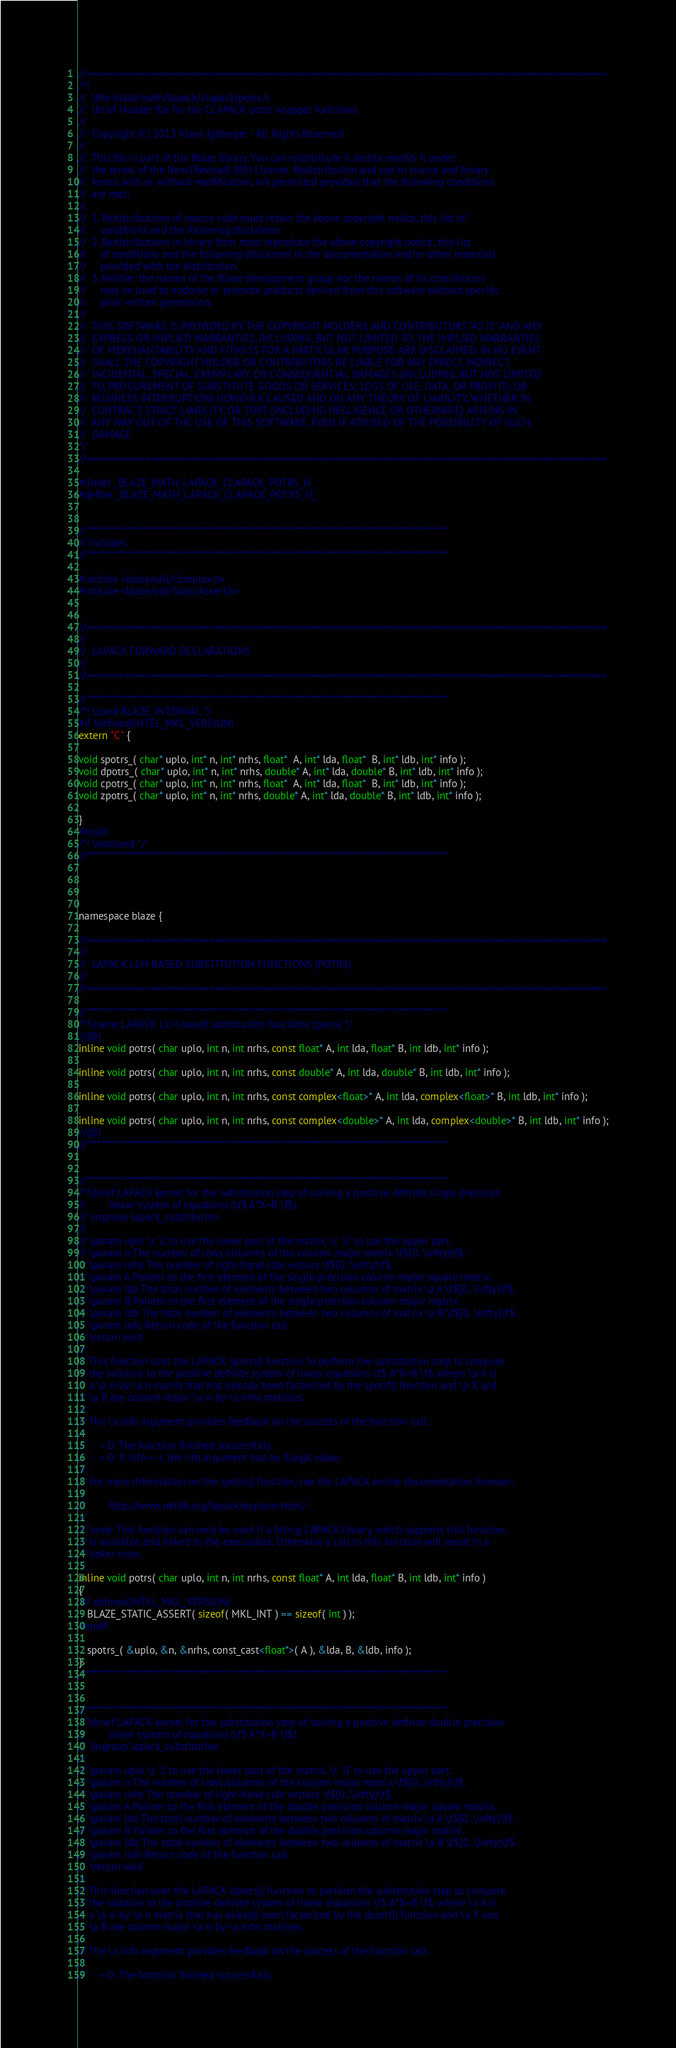Convert code to text. <code><loc_0><loc_0><loc_500><loc_500><_C_>//=================================================================================================
/*!
//  \file blaze/math/lapack/clapack/potrs.h
//  \brief Header file for the CLAPACK potrs wrapper functions
//
//  Copyright (C) 2013 Klaus Iglberger - All Rights Reserved
//
//  This file is part of the Blaze library. You can redistribute it and/or modify it under
//  the terms of the New (Revised) BSD License. Redistribution and use in source and binary
//  forms, with or without modification, are permitted provided that the following conditions
//  are met:
//
//  1. Redistributions of source code must retain the above copyright notice, this list of
//     conditions and the following disclaimer.
//  2. Redistributions in binary form must reproduce the above copyright notice, this list
//     of conditions and the following disclaimer in the documentation and/or other materials
//     provided with the distribution.
//  3. Neither the names of the Blaze development group nor the names of its contributors
//     may be used to endorse or promote products derived from this software without specific
//     prior written permission.
//
//  THIS SOFTWARE IS PROVIDED BY THE COPYRIGHT HOLDERS AND CONTRIBUTORS "AS IS" AND ANY
//  EXPRESS OR IMPLIED WARRANTIES, INCLUDING, BUT NOT LIMITED TO, THE IMPLIED WARRANTIES
//  OF MERCHANTABILITY AND FITNESS FOR A PARTICULAR PURPOSE ARE DISCLAIMED. IN NO EVENT
//  SHALL THE COPYRIGHT HOLDER OR CONTRIBUTORS BE LIABLE FOR ANY DIRECT, INDIRECT,
//  INCIDENTAL, SPECIAL, EXEMPLARY, OR CONSEQUENTIAL DAMAGES (INCLUDING, BUT NOT LIMITED
//  TO, PROCUREMENT OF SUBSTITUTE GOODS OR SERVICES; LOSS OF USE, DATA, OR PROFITS; OR
//  BUSINESS INTERRUPTION) HOWEVER CAUSED AND ON ANY THEORY OF LIABILITY, WHETHER IN
//  CONTRACT, STRICT LIABILITY, OR TORT (INCLUDING NEGLIGENCE OR OTHERWISE) ARISING IN
//  ANY WAY OUT OF THE USE OF THIS SOFTWARE, EVEN IF ADVISED OF THE POSSIBILITY OF SUCH
//  DAMAGE.
*/
//=================================================================================================

#ifndef _BLAZE_MATH_LAPACK_CLAPACK_POTRS_H_
#define _BLAZE_MATH_LAPACK_CLAPACK_POTRS_H_


//*************************************************************************************************
// Includes
//*************************************************************************************************

#include <blaze/util/Complex.h>
#include <blaze/util/StaticAssert.h>


//=================================================================================================
//
//  LAPACK FORWARD DECLARATIONS
//
//=================================================================================================

//*************************************************************************************************
/*! \cond BLAZE_INTERNAL */
#if !defined(INTEL_MKL_VERSION)
extern "C" {

void spotrs_( char* uplo, int* n, int* nrhs, float*  A, int* lda, float*  B, int* ldb, int* info );
void dpotrs_( char* uplo, int* n, int* nrhs, double* A, int* lda, double* B, int* ldb, int* info );
void cpotrs_( char* uplo, int* n, int* nrhs, float*  A, int* lda, float*  B, int* ldb, int* info );
void zpotrs_( char* uplo, int* n, int* nrhs, double* A, int* lda, double* B, int* ldb, int* info );

}
#endif
/*! \endcond */
//*************************************************************************************************




namespace blaze {

//=================================================================================================
//
//  LAPACK LLH-BASED SUBSTITUTION FUNCTIONS (POTRS)
//
//=================================================================================================

//*************************************************************************************************
/*!\name LAPACK LLH-based substitution functions (potrs) */
//@{
inline void potrs( char uplo, int n, int nrhs, const float* A, int lda, float* B, int ldb, int* info );

inline void potrs( char uplo, int n, int nrhs, const double* A, int lda, double* B, int ldb, int* info );

inline void potrs( char uplo, int n, int nrhs, const complex<float>* A, int lda, complex<float>* B, int ldb, int* info );

inline void potrs( char uplo, int n, int nrhs, const complex<double>* A, int lda, complex<double>* B, int ldb, int* info );
//@}
//*************************************************************************************************


//*************************************************************************************************
/*!\brief LAPACK kernel for the substitution step of solving a positive definite single precision
//        linear system of equations (\f$ A*X=B \f$).
// \ingroup lapack_substitution
//
// \param uplo \c 'L' to use the lower part of the matrix, \c 'U' to use the upper part.
// \param n The number of rows/columns of the column-major matrix \f$[0..\infty)\f$.
// \param nrhs The number of right-hand side vectors \f$[0..\infty)\f$.
// \param A Pointer to the first element of the single precision column-major square matrix.
// \param lda The total number of elements between two columns of matrix \a A \f$[0..\infty)\f$.
// \param B Pointer to the first element of the single precision column-major matrix.
// \param ldb The total number of elements between two columns of matrix \a B \f$[0..\infty)\f$.
// \param info Return code of the function call.
// \return void
//
// This function uses the LAPACK spotrs() function to perform the substitution step to compute
// the solution to the positive definite system of linear equations \f$ A*X=B \f$, where \a A is
// a \a n-by-\a n matrix that has already been factorized by the spotrf() function and \a X and
// \a B are column-major \a n-by-\a nrhs matrices.
//
// The \a info argument provides feedback on the success of the function call:
//
//   - = 0: The function finished successfully.
//   - < 0: If info = -i, the i-th argument had an illegal value.
//
// For more information on the spotrs() function, see the LAPACK online documentation browser:
//
//        http://www.netlib.org/lapack/explore-html/
//
// \note This function can only be used if a fitting LAPACK library, which supports this function,
// is available and linked to the executable. Otherwise a call to this function will result in a
// linker error.
*/
inline void potrs( char uplo, int n, int nrhs, const float* A, int lda, float* B, int ldb, int* info )
{
#if defined(INTEL_MKL_VERSION)
   BLAZE_STATIC_ASSERT( sizeof( MKL_INT ) == sizeof( int ) );
#endif

   spotrs_( &uplo, &n, &nrhs, const_cast<float*>( A ), &lda, B, &ldb, info );
}
//*************************************************************************************************


//*************************************************************************************************
/*!\brief LAPACK kernel for the substitution step of solving a positive definite double precision
//        linear system of equations (\f$ A*X=B \f$).
// \ingroup lapack_substitution
//
// \param uplo \c 'L' to use the lower part of the matrix, \c 'U' to use the upper part.
// \param n The number of rows/columns of the column-major matrix \f$[0..\infty)\f$.
// \param nrhs The number of right-hand side vectors \f$[0..\infty)\f$.
// \param A Pointer to the first element of the double precision column-major square matrix.
// \param lda The total number of elements between two columns of matrix \a A \f$[0..\infty)\f$.
// \param B Pointer to the first element of the double precision column-major matrix.
// \param ldb The total number of elements between two columns of matrix \a B \f$[0..\infty)\f$.
// \param info Return code of the function call.
// \return void
//
// This function uses the LAPACK dpotrs() function to perform the substitution step to compute
// the solution to the positive definite system of linear equations \f$ A*X=B \f$, where \a A is
// a \a n-by-\a n matrix that has already been factorized by the dpotrf() function and \a X and
// \a B are column-major \a n-by-\a nrhs matrices.
//
// The \a info argument provides feedback on the success of the function call:
//
//   - = 0: The function finished successfully.</code> 